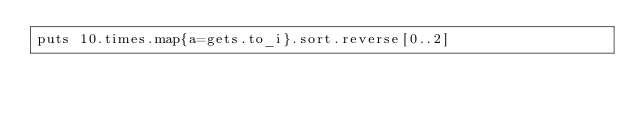Convert code to text. <code><loc_0><loc_0><loc_500><loc_500><_Ruby_>puts 10.times.map{a=gets.to_i}.sort.reverse[0..2]</code> 